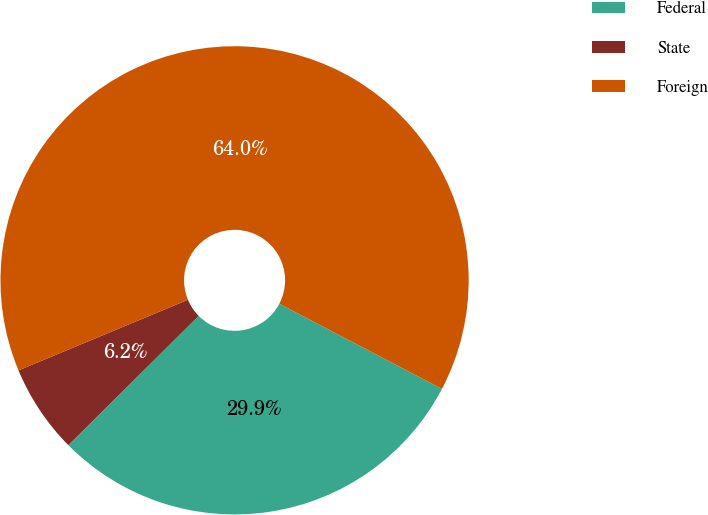<chart> <loc_0><loc_0><loc_500><loc_500><pie_chart><fcel>Federal<fcel>State<fcel>Foreign<nl><fcel>29.89%<fcel>6.15%<fcel>63.96%<nl></chart> 